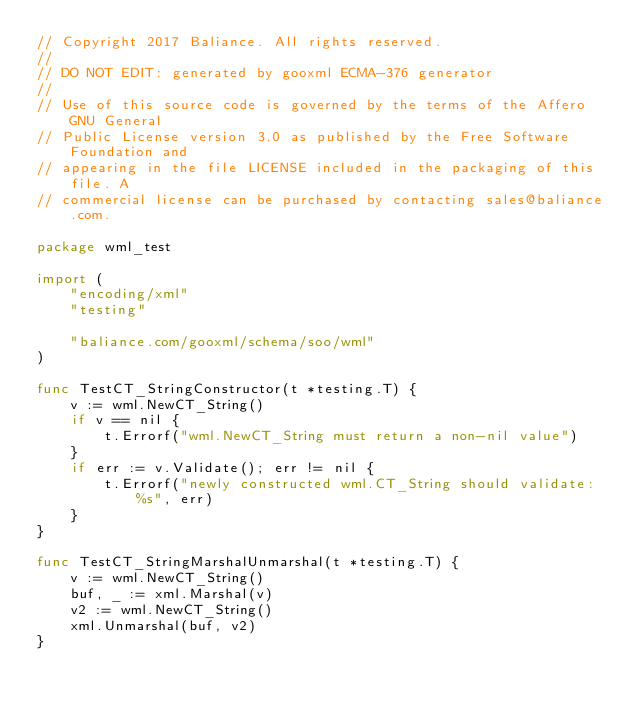Convert code to text. <code><loc_0><loc_0><loc_500><loc_500><_Go_>// Copyright 2017 Baliance. All rights reserved.
//
// DO NOT EDIT: generated by gooxml ECMA-376 generator
//
// Use of this source code is governed by the terms of the Affero GNU General
// Public License version 3.0 as published by the Free Software Foundation and
// appearing in the file LICENSE included in the packaging of this file. A
// commercial license can be purchased by contacting sales@baliance.com.

package wml_test

import (
	"encoding/xml"
	"testing"

	"baliance.com/gooxml/schema/soo/wml"
)

func TestCT_StringConstructor(t *testing.T) {
	v := wml.NewCT_String()
	if v == nil {
		t.Errorf("wml.NewCT_String must return a non-nil value")
	}
	if err := v.Validate(); err != nil {
		t.Errorf("newly constructed wml.CT_String should validate: %s", err)
	}
}

func TestCT_StringMarshalUnmarshal(t *testing.T) {
	v := wml.NewCT_String()
	buf, _ := xml.Marshal(v)
	v2 := wml.NewCT_String()
	xml.Unmarshal(buf, v2)
}
</code> 